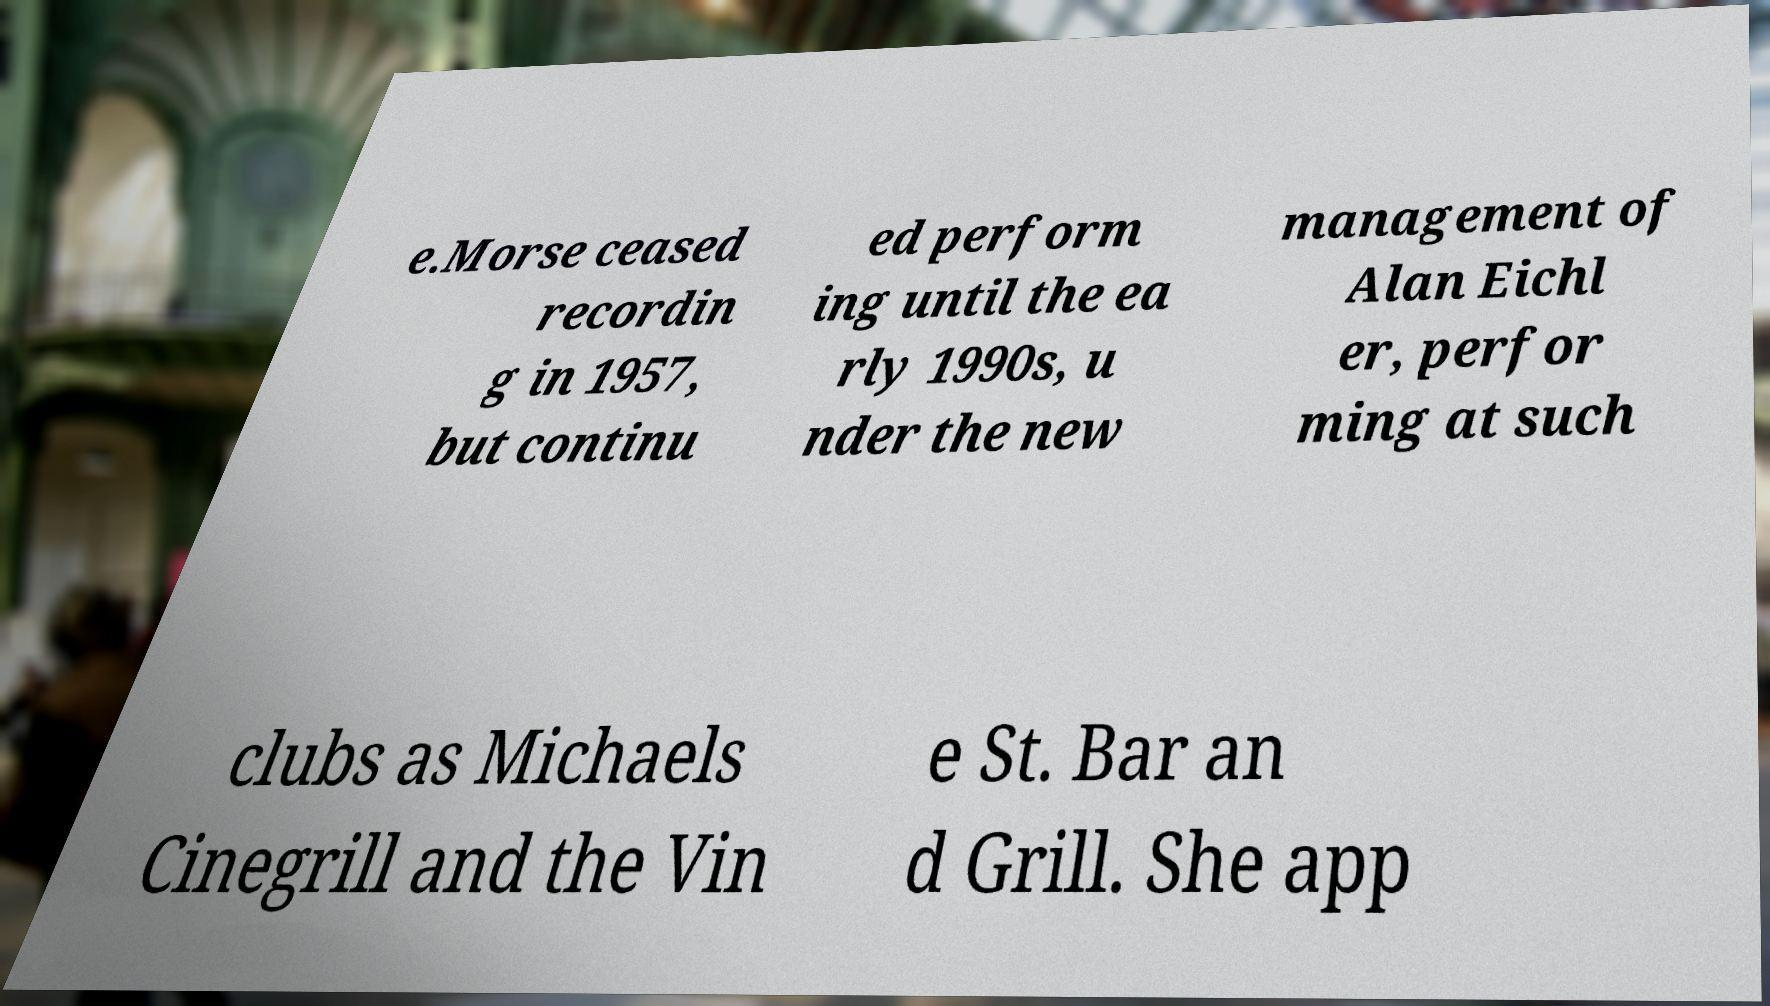Can you read and provide the text displayed in the image?This photo seems to have some interesting text. Can you extract and type it out for me? e.Morse ceased recordin g in 1957, but continu ed perform ing until the ea rly 1990s, u nder the new management of Alan Eichl er, perfor ming at such clubs as Michaels Cinegrill and the Vin e St. Bar an d Grill. She app 